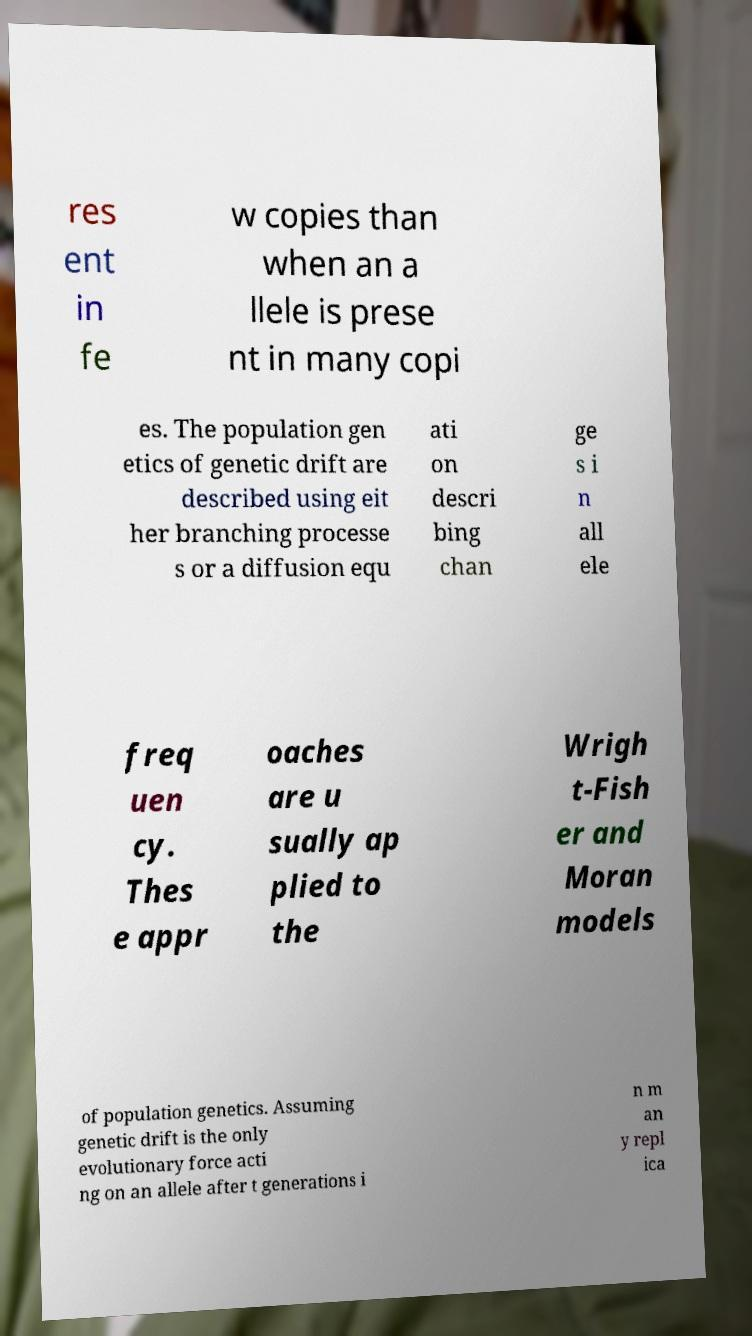Can you read and provide the text displayed in the image?This photo seems to have some interesting text. Can you extract and type it out for me? res ent in fe w copies than when an a llele is prese nt in many copi es. The population gen etics of genetic drift are described using eit her branching processe s or a diffusion equ ati on descri bing chan ge s i n all ele freq uen cy. Thes e appr oaches are u sually ap plied to the Wrigh t-Fish er and Moran models of population genetics. Assuming genetic drift is the only evolutionary force acti ng on an allele after t generations i n m an y repl ica 